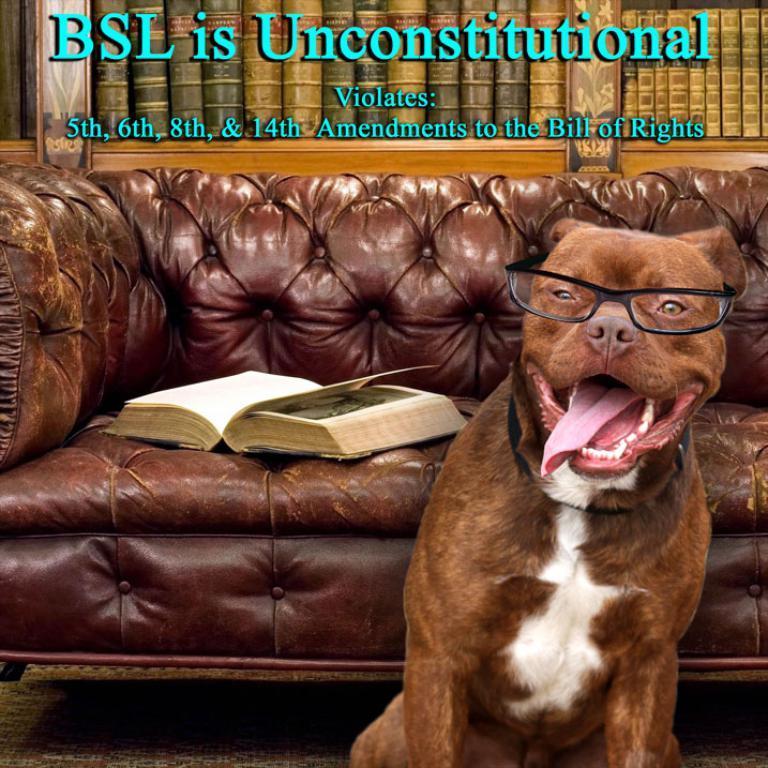Describe this image in one or two sentences. In front of the image there is a dog, behind the dog there is a book on the couch, behind the couch there are books on the bookshelf. At the top of the image there is some text. 